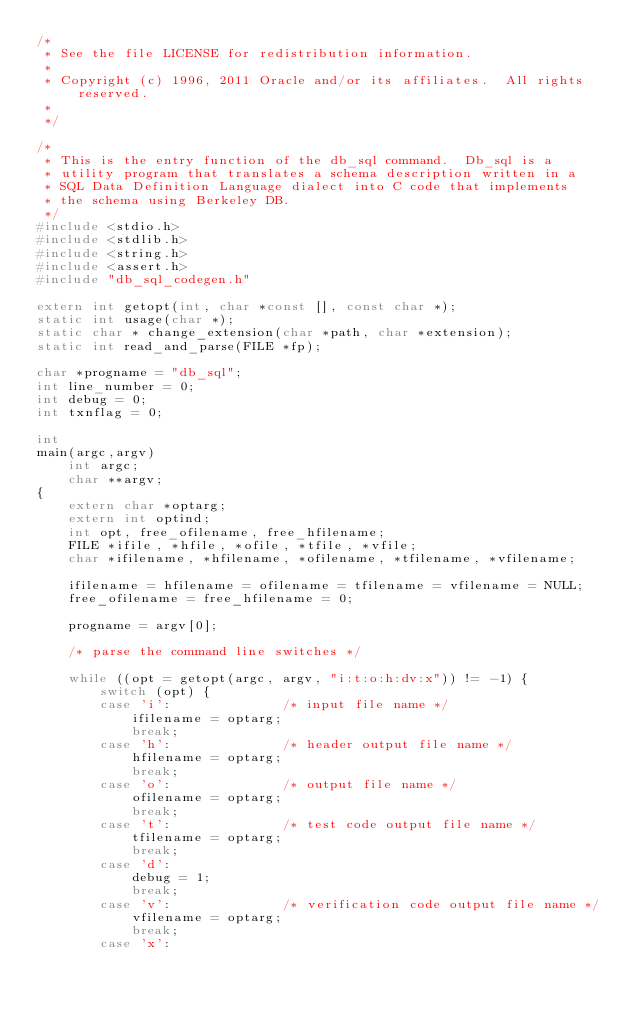<code> <loc_0><loc_0><loc_500><loc_500><_C_>/*
 * See the file LICENSE for redistribution information.
 *
 * Copyright (c) 1996, 2011 Oracle and/or its affiliates.  All rights reserved.
 *
 */

/*
 * This is the entry function of the db_sql command.  Db_sql is a
 * utility program that translates a schema description written in a
 * SQL Data Definition Language dialect into C code that implements
 * the schema using Berkeley DB.
 */
#include <stdio.h>
#include <stdlib.h>
#include <string.h>
#include <assert.h>
#include "db_sql_codegen.h"

extern int getopt(int, char *const [], const char *);
static int usage(char *);
static char * change_extension(char *path, char *extension);
static int read_and_parse(FILE *fp);

char *progname = "db_sql";
int line_number = 0;
int debug = 0;
int txnflag = 0;

int
main(argc,argv)
	int argc;
	char **argv;
{
	extern char *optarg;
	extern int optind;
	int opt, free_ofilename, free_hfilename;
	FILE *ifile, *hfile, *ofile, *tfile, *vfile;
	char *ifilename, *hfilename, *ofilename, *tfilename, *vfilename;

	ifilename = hfilename = ofilename = tfilename = vfilename = NULL;
	free_ofilename = free_hfilename = 0;

	progname = argv[0];

	/* parse the command line switches */

	while ((opt = getopt(argc, argv, "i:t:o:h:dv:x")) != -1) {
		switch (opt) {
		case 'i':              /* input file name */
			ifilename = optarg;
			break;
		case 'h':              /* header output file name */
			hfilename = optarg;
			break;
		case 'o':              /* output file name */
			ofilename = optarg;
			break;
		case 't':              /* test code output file name */
			tfilename = optarg;
			break;
		case 'd':
			debug = 1;
			break;
		case 'v':              /* verification code output file name */
			vfilename = optarg;
			break;
		case 'x':</code> 